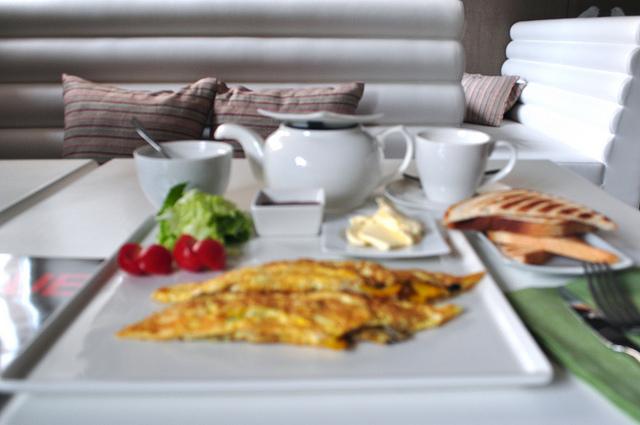What color is the teapot?
Concise answer only. White. What meal is being served?
Short answer required. Breakfast. Do you see lettuce?
Write a very short answer. Yes. 